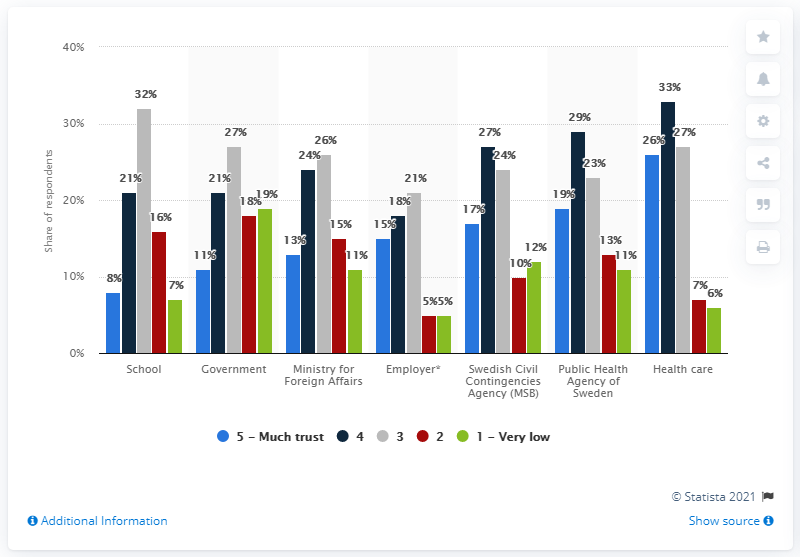List a handful of essential elements in this visual. According to the survey, 11% of the respondents stated that they had a great deal of trust in the Swedish government. 